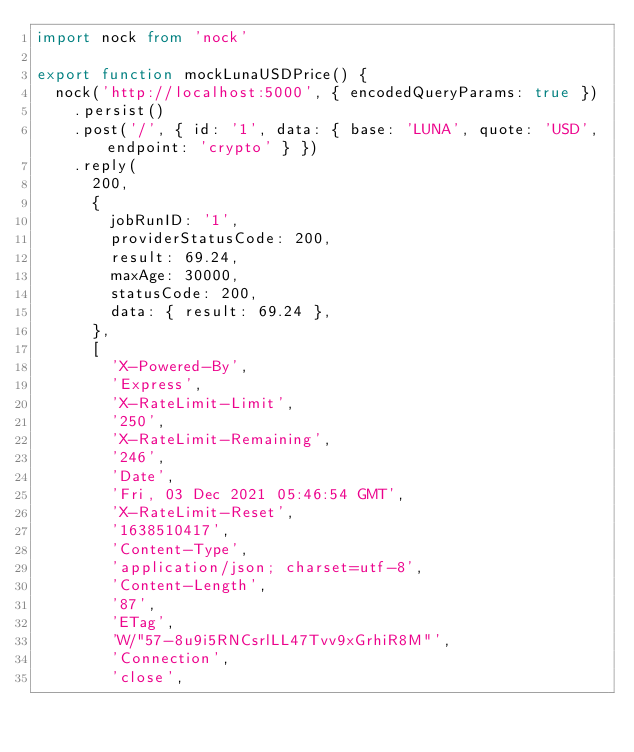<code> <loc_0><loc_0><loc_500><loc_500><_TypeScript_>import nock from 'nock'

export function mockLunaUSDPrice() {
  nock('http://localhost:5000', { encodedQueryParams: true })
    .persist()
    .post('/', { id: '1', data: { base: 'LUNA', quote: 'USD', endpoint: 'crypto' } })
    .reply(
      200,
      {
        jobRunID: '1',
        providerStatusCode: 200,
        result: 69.24,
        maxAge: 30000,
        statusCode: 200,
        data: { result: 69.24 },
      },
      [
        'X-Powered-By',
        'Express',
        'X-RateLimit-Limit',
        '250',
        'X-RateLimit-Remaining',
        '246',
        'Date',
        'Fri, 03 Dec 2021 05:46:54 GMT',
        'X-RateLimit-Reset',
        '1638510417',
        'Content-Type',
        'application/json; charset=utf-8',
        'Content-Length',
        '87',
        'ETag',
        'W/"57-8u9i5RNCsrlLL47Tvv9xGrhiR8M"',
        'Connection',
        'close',</code> 